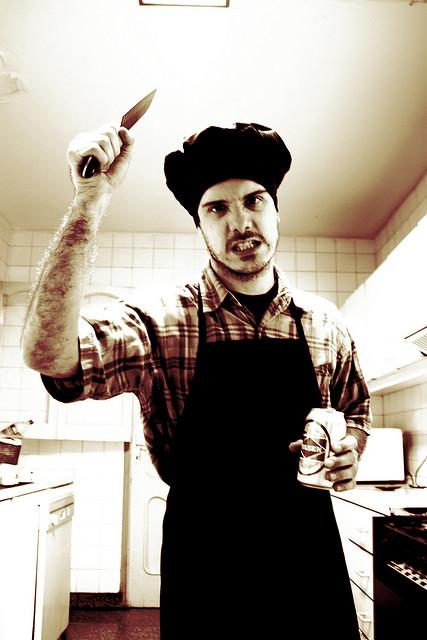What is the artwork on the man's arm?
Be succinct. Tattoo. Is this room the kitchen?
Quick response, please. Yes. What is the man holding in his left hand?
Concise answer only. Knife. 